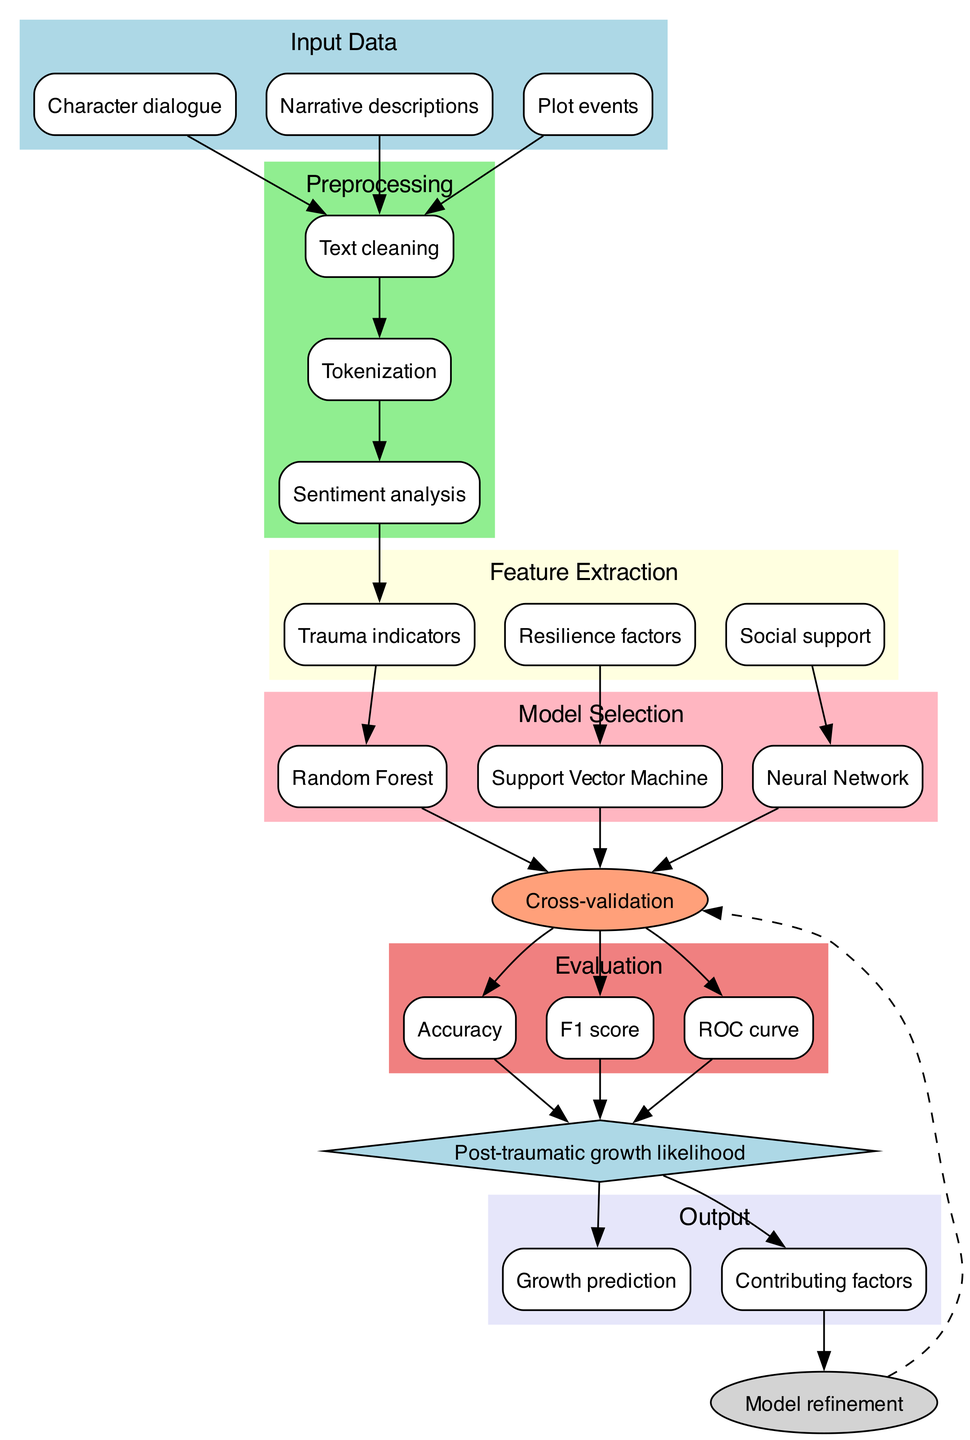What are the input data types in this pipeline? The diagram specifies three input data types: Character dialogue, Narrative descriptions, and Plot events.
Answer: Character dialogue, Narrative descriptions, Plot events How many nodes are present in the model selection phase? There are three options listed for model selection: Random Forest, Support Vector Machine, and Neural Network, which totals to three nodes.
Answer: 3 Which model is selected for training based on trauma indicators? The diagram shows that the Trauma indicators connect to the Random Forest model, indicating it is the model selected for training based on this feature.
Answer: Random Forest What is the relationship between the evaluation metrics and the prediction? The evaluation metrics (Accuracy, F1 score, ROC curve) all point to the Prediction node, which suggests their output is utilized to inform the prediction of post-traumatic growth likelihood.
Answer: They point to Prediction How does the feedback loop relate to the training process? The Feedback node connects back to the Training node with a dashed line, indicating that feedback from the output contributes to refining the training process, emphasizing an iterative improvement loop.
Answer: It refines the training process What factors are involved in feature extraction? The diagram lists three feature extraction factors: Trauma indicators, Resilience factors, and Social support, which are essential for creating the feature set used for prediction.
Answer: Trauma indicators, Resilience factors, Social support What type of diagram is this and what is its primary purpose? This is a Machine Learning Diagram that illustrates the steps taken to predict post-traumatic growth likelihood in fictional characters through a series of analytical phases.
Answer: Machine Learning Diagram, predicting post-traumatic growth likelihood Which output nodes are generated from the prediction? The prediction node leads to two output nodes: Growth prediction and Contributing factors, indicating these are the results of the machine learning process.
Answer: Growth prediction, Contributing factors 